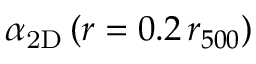<formula> <loc_0><loc_0><loc_500><loc_500>\alpha _ { 2 D } \, ( r = 0 . 2 \, r _ { 5 0 0 } )</formula> 